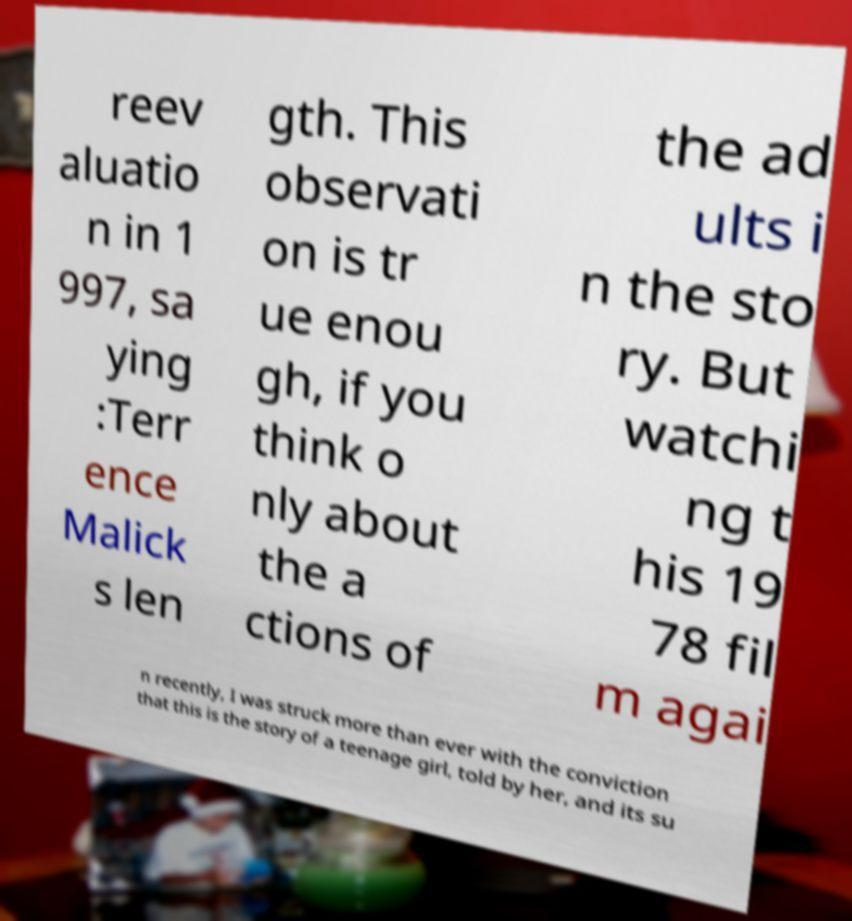There's text embedded in this image that I need extracted. Can you transcribe it verbatim? reev aluatio n in 1 997, sa ying :Terr ence Malick s len gth. This observati on is tr ue enou gh, if you think o nly about the a ctions of the ad ults i n the sto ry. But watchi ng t his 19 78 fil m agai n recently, I was struck more than ever with the conviction that this is the story of a teenage girl, told by her, and its su 